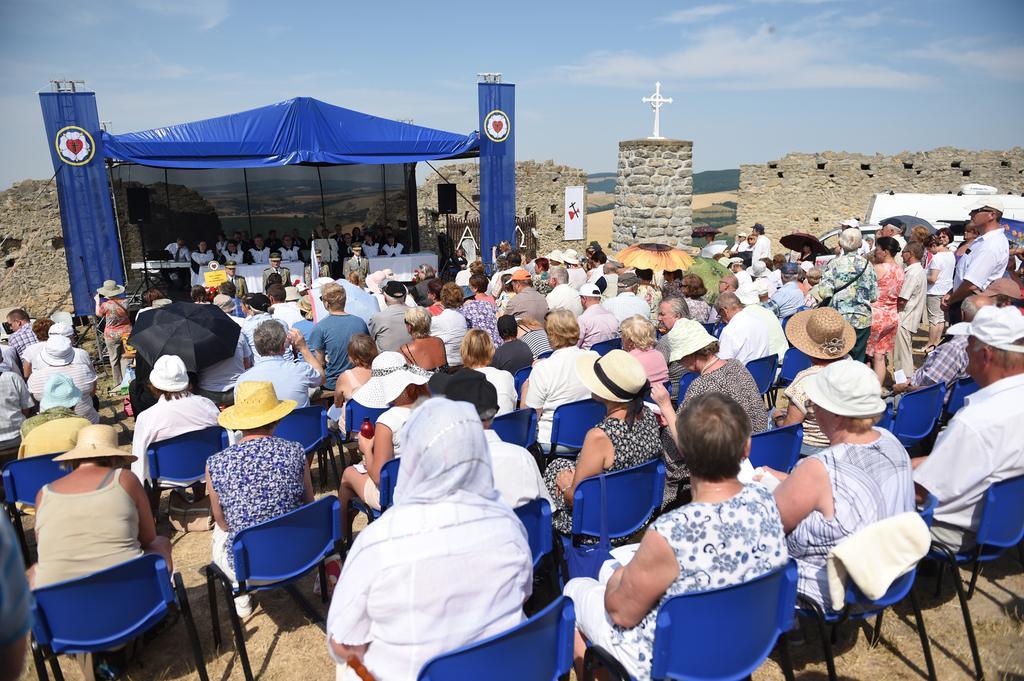Describe this image in one or two sentences. The picture is taken outside a house or may be a church. In this picture there is a gathering for prayer. In the foreground there are people sitting on chairs and few are standing. In the center of the picture there are people, table, tent, cross, wall, car and other objects. In the background there are hills. Sky is sunny. 